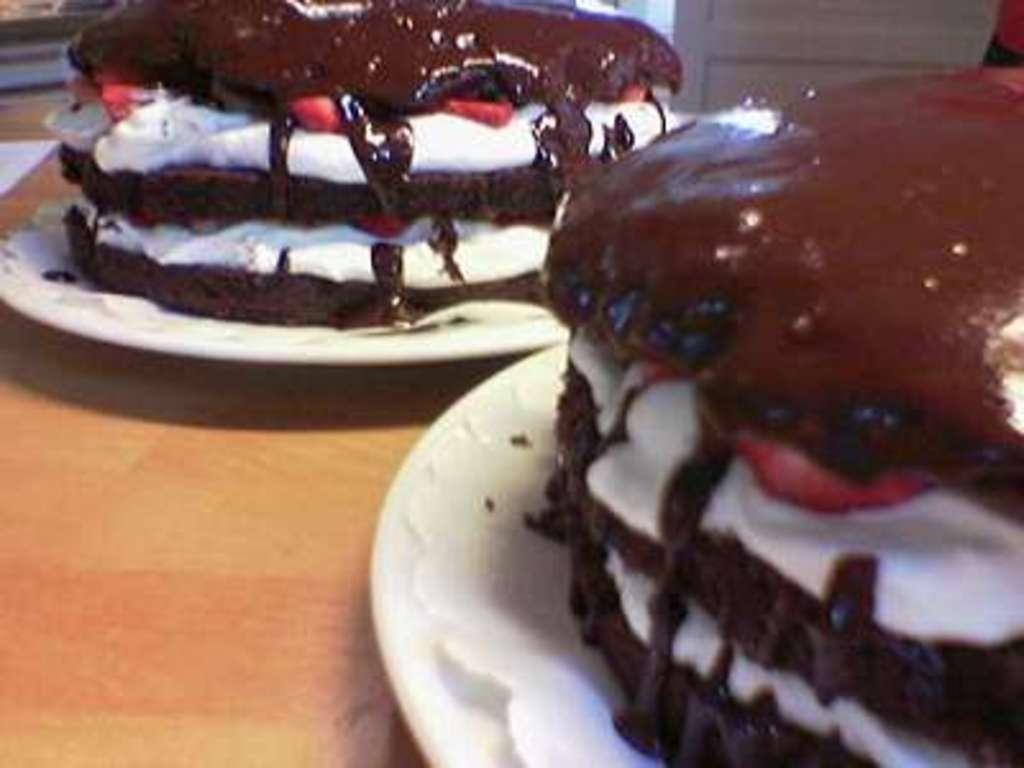What piece of furniture is present in the image? There is a table in the image. What is placed on the table? There is a plate on the table. What is on the plate? The plate contains papers and cakes. How does the glass tank kick the ball in the image? There is no glass tank or ball present in the image. 